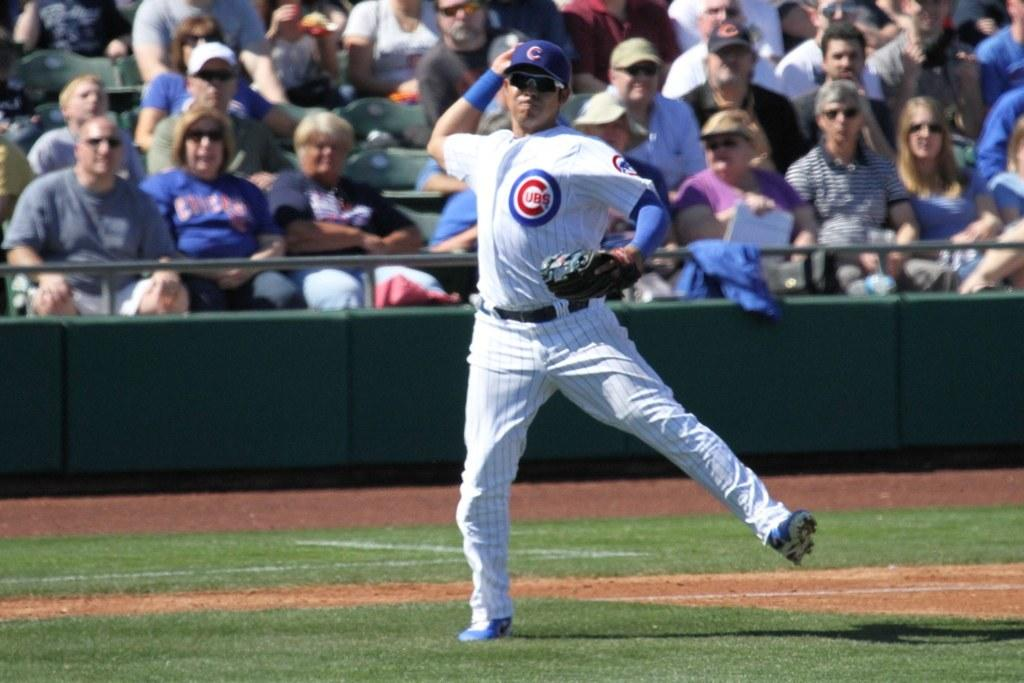<image>
Write a terse but informative summary of the picture. A baseball player throwing a ball wearing a shirt that says Cubs on it. 